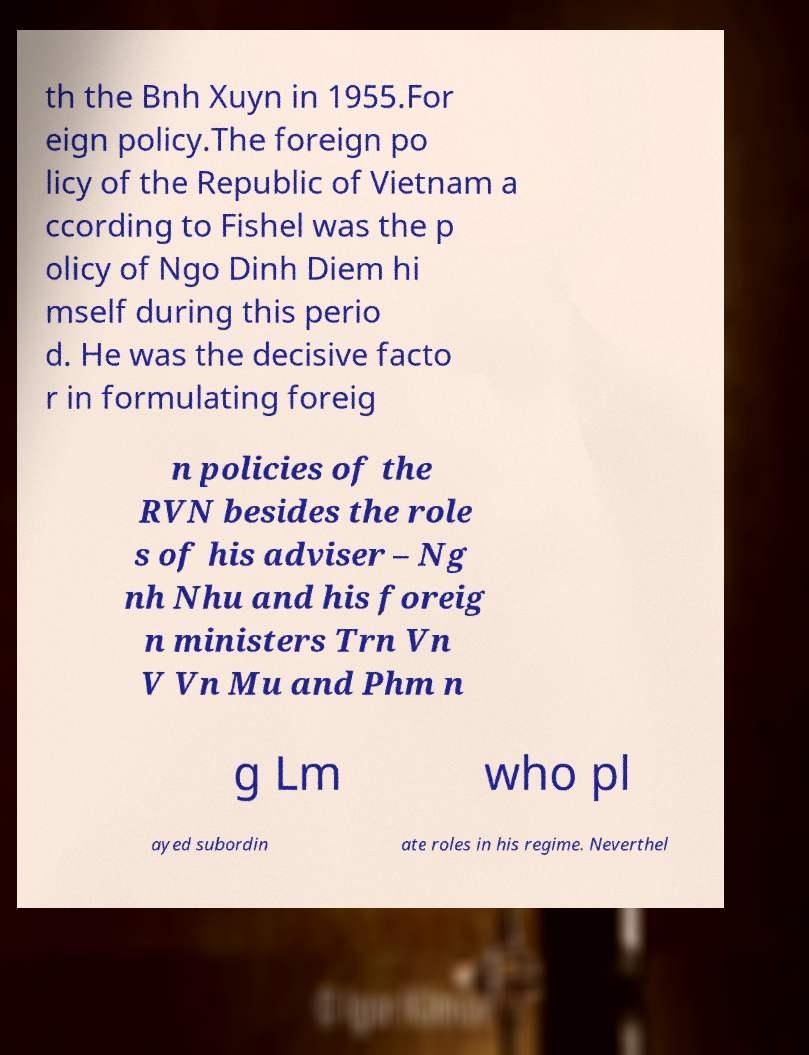What messages or text are displayed in this image? I need them in a readable, typed format. th the Bnh Xuyn in 1955.For eign policy.The foreign po licy of the Republic of Vietnam a ccording to Fishel was the p olicy of Ngo Dinh Diem hi mself during this perio d. He was the decisive facto r in formulating foreig n policies of the RVN besides the role s of his adviser – Ng nh Nhu and his foreig n ministers Trn Vn V Vn Mu and Phm n g Lm who pl ayed subordin ate roles in his regime. Neverthel 